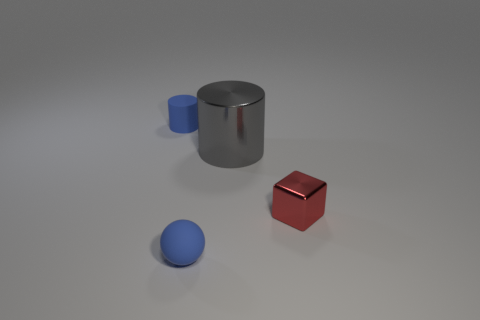If these objects were used in a game, what could their purposes be? In a game, the cylinder might serve as a container or a barrel, the cube could be a crate or a puzzle piece, and the sphere might be used as a projectile or a collectible item. 